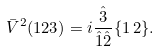<formula> <loc_0><loc_0><loc_500><loc_500>\bar { V } ^ { 2 } ( 1 2 3 ) = i \frac { \hat { 3 } } { \hat { 1 } \hat { 2 } } \{ 1 \, 2 \} .</formula> 